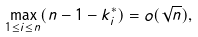<formula> <loc_0><loc_0><loc_500><loc_500>\max _ { 1 \leq i \leq n } ( n - 1 - k ^ { * } _ { i } ) = o ( \sqrt { n } ) ,</formula> 